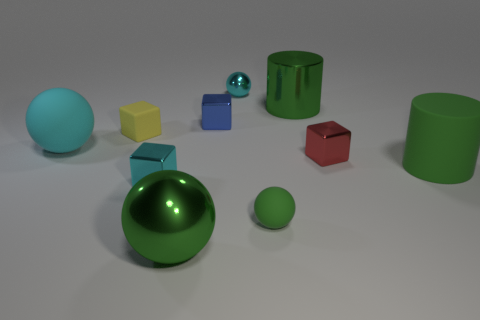Subtract 1 cubes. How many cubes are left? 3 Subtract all cubes. How many objects are left? 6 Subtract 0 purple spheres. How many objects are left? 10 Subtract all small red things. Subtract all blue cubes. How many objects are left? 8 Add 7 tiny green objects. How many tiny green objects are left? 8 Add 3 tiny blue shiny blocks. How many tiny blue shiny blocks exist? 4 